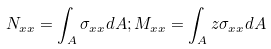<formula> <loc_0><loc_0><loc_500><loc_500>N _ { x x } = \int _ { A } \sigma _ { x x } d A ; M _ { x x } = \int _ { A } z \sigma _ { x x } d A</formula> 